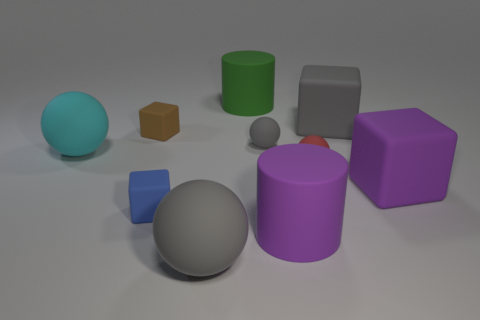How many other objects are there of the same shape as the red matte object?
Your answer should be compact. 3. How many brown objects are either small rubber objects or big rubber blocks?
Your answer should be compact. 1. Is the red matte thing the same shape as the tiny blue matte object?
Provide a short and direct response. No. Are there any red rubber things that are to the right of the large purple thing that is on the right side of the red ball?
Provide a short and direct response. No. Are there the same number of small cubes behind the tiny red ball and gray matte blocks?
Offer a very short reply. Yes. How many other objects are the same size as the purple matte cube?
Ensure brevity in your answer.  5. Do the tiny block that is to the left of the blue block and the large cube in front of the brown cube have the same material?
Offer a terse response. Yes. What size is the gray matte sphere behind the big rubber ball that is on the right side of the small blue rubber block?
Ensure brevity in your answer.  Small. There is a big ball that is on the right side of the cyan ball; is it the same color as the big matte cube behind the tiny gray rubber thing?
Offer a terse response. Yes. The red rubber object is what shape?
Your response must be concise. Sphere. 